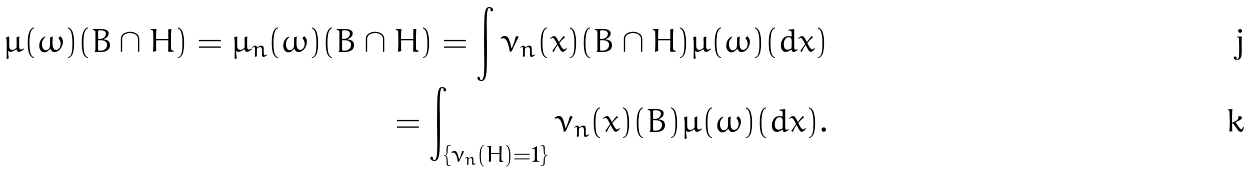<formula> <loc_0><loc_0><loc_500><loc_500>\mu ( \omega ) ( B \cap H ) = \mu _ { n } ( \omega ) ( B \cap H ) = \int \nu _ { n } ( x ) ( B \cap H ) \mu ( \omega ) ( d x ) \\ = \int _ { \{ \nu _ { n } ( H ) = 1 \} } \nu _ { n } ( x ) ( B ) \mu ( \omega ) ( d x ) .</formula> 